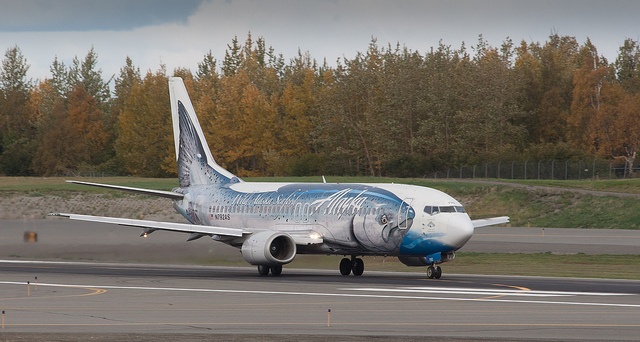<image>Where is this plane going? I don't know where this plane is going. It could be going to Alaska, Kentucky, or to the terminal. Where is this plane going? I am not sure where this plane is going. It can be going to Alaska. 